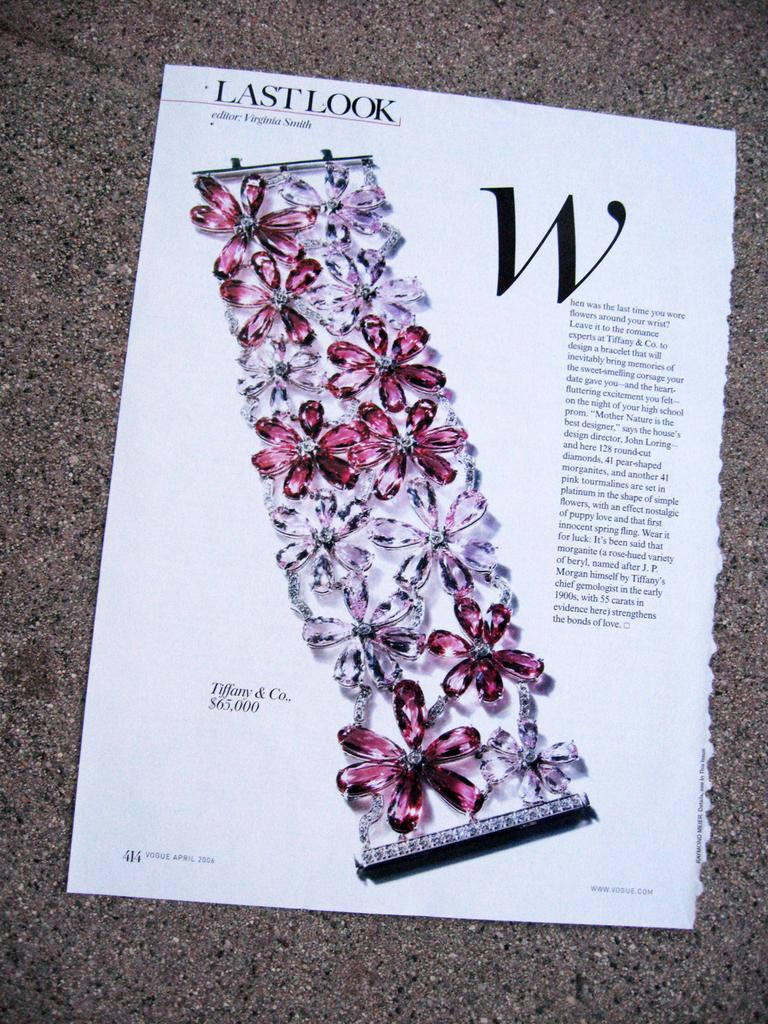What is present on the paper in the image? The paper contains text and a picture of an ornament. Can you describe the text on the paper? Unfortunately, the specific content of the text cannot be determined from the image. What type of ornament is depicted on the paper? The image does not provide enough detail to identify the specific type of ornament. What color is the wristwatch depicted on the paper? There is no wristwatch depicted on the paper; it features a picture of an ornament. What activity is taking place in the image? The image does not depict any specific activity; it simply shows a paper with text and an ornament. 